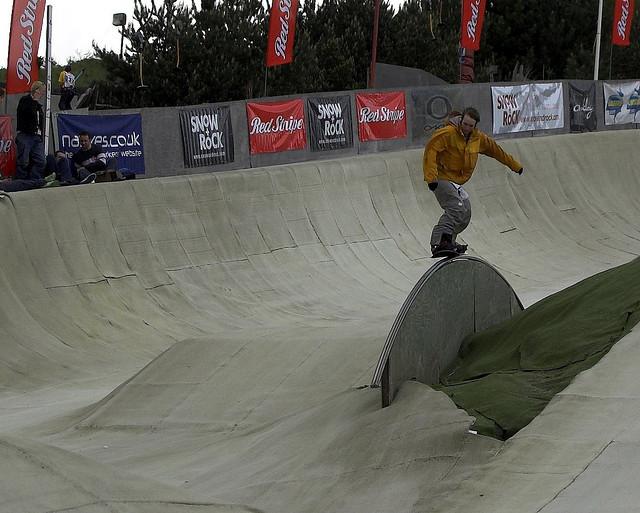What is the man wearing?
Answer briefly. Jacket. How many people are in the photo?
Be succinct. 4. Is his jacket hooded?
Write a very short answer. Yes. Is the guy keeping his balance?
Quick response, please. Yes. 